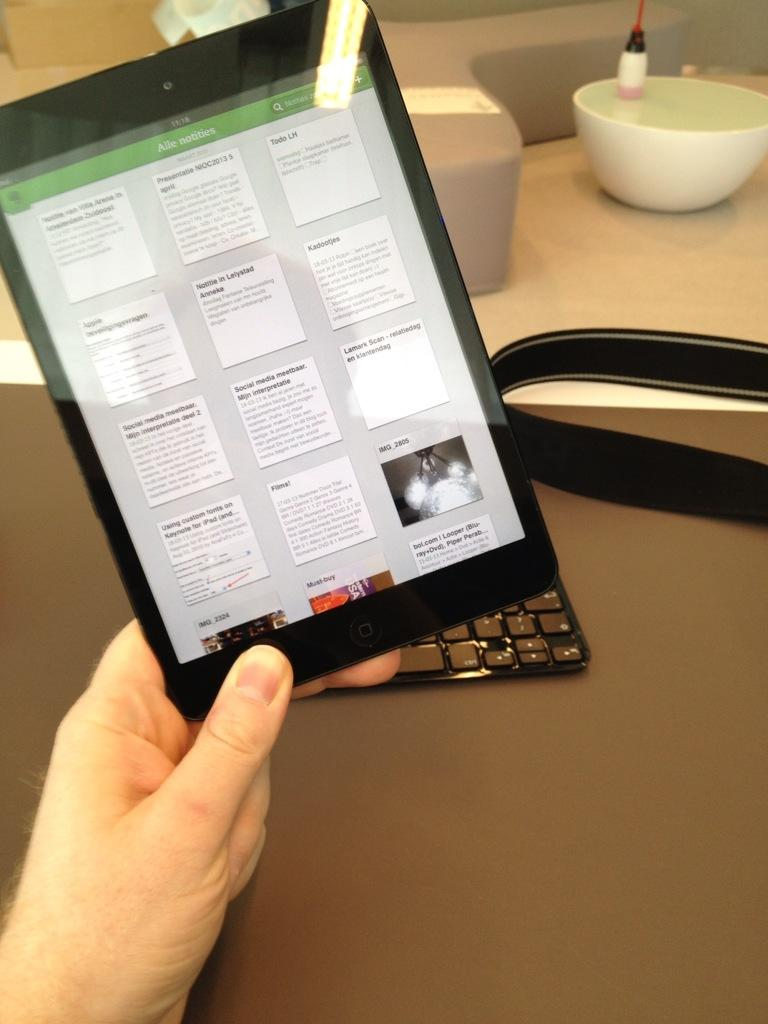What is the person's hand holding in the image? The person's hand is holding a tab in the image. What can be found inside the bowl in the image? There is an object in the bowl in the image. What type of device is visible in the image? There is a keyboard in the image. What other objects can be seen on the table in the image? There are other objects on the table in the image. What type of stitch is being used to sew the cellar in the image? There is no mention of a cellar or stitching in the image; it features a person's hand holding a tab, a bowl with an object, a keyboard, and other objects on a table. 